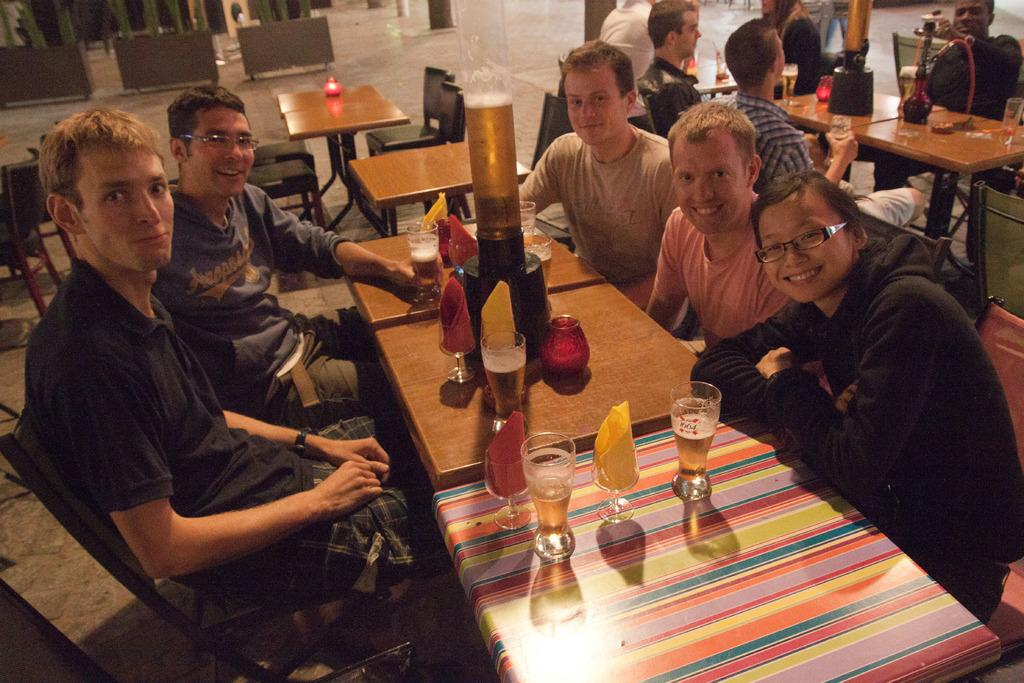How many persons are in the group visible in the image? There is a group of persons in the image. What are the persons in the image doing? The persons are sitting. What activity are the persons engaged in while sitting? The persons are having their drinks. What type of joke can be seen on the roof in the image? There is no joke or roof present in the image. What type of growth can be observed on the persons in the image? There is no growth visible on the persons in the image; the focus is on their sitting and having drinks. 